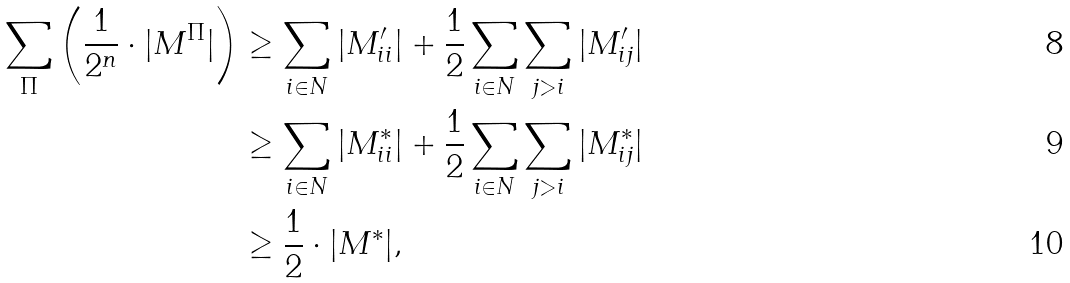Convert formula to latex. <formula><loc_0><loc_0><loc_500><loc_500>\sum _ { \Pi } \left ( \frac { 1 } { 2 ^ { n } } \cdot | M ^ { \Pi } | \right ) & \geq \sum _ { i \in N } | M ^ { \prime } _ { i i } | + \frac { 1 } { 2 } \sum _ { i \in N } \sum _ { j > i } | M ^ { \prime } _ { i j } | \\ & \geq \sum _ { i \in N } | M ^ { * } _ { i i } | + \frac { 1 } { 2 } \sum _ { i \in N } \sum _ { j > i } | M ^ { * } _ { i j } | \\ & \geq \frac { 1 } { 2 } \cdot | M ^ { * } | ,</formula> 